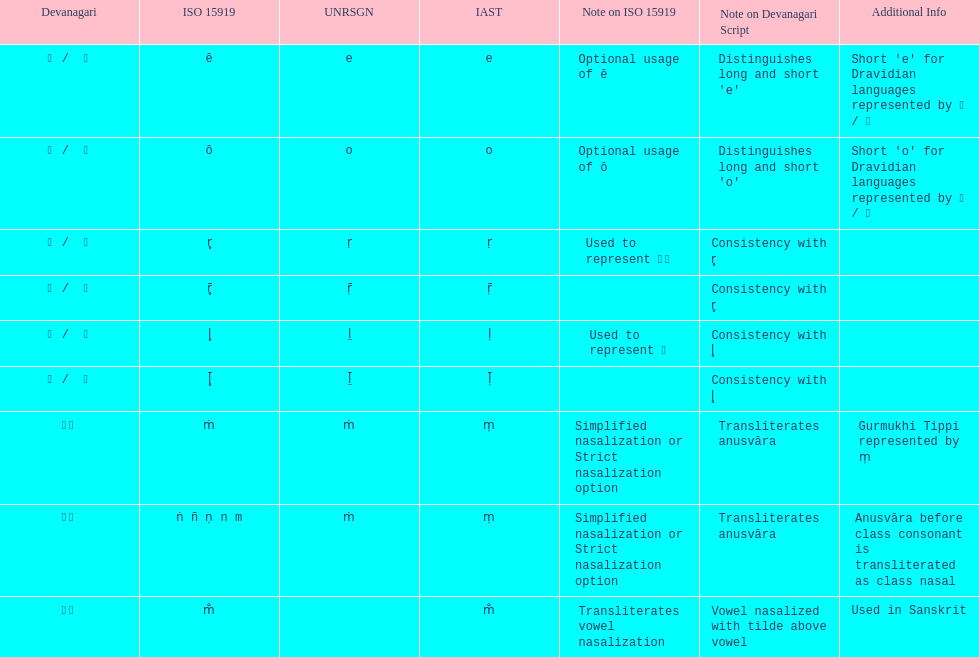Which devanagari transliteration is listed on the top of the table? ए / े. 